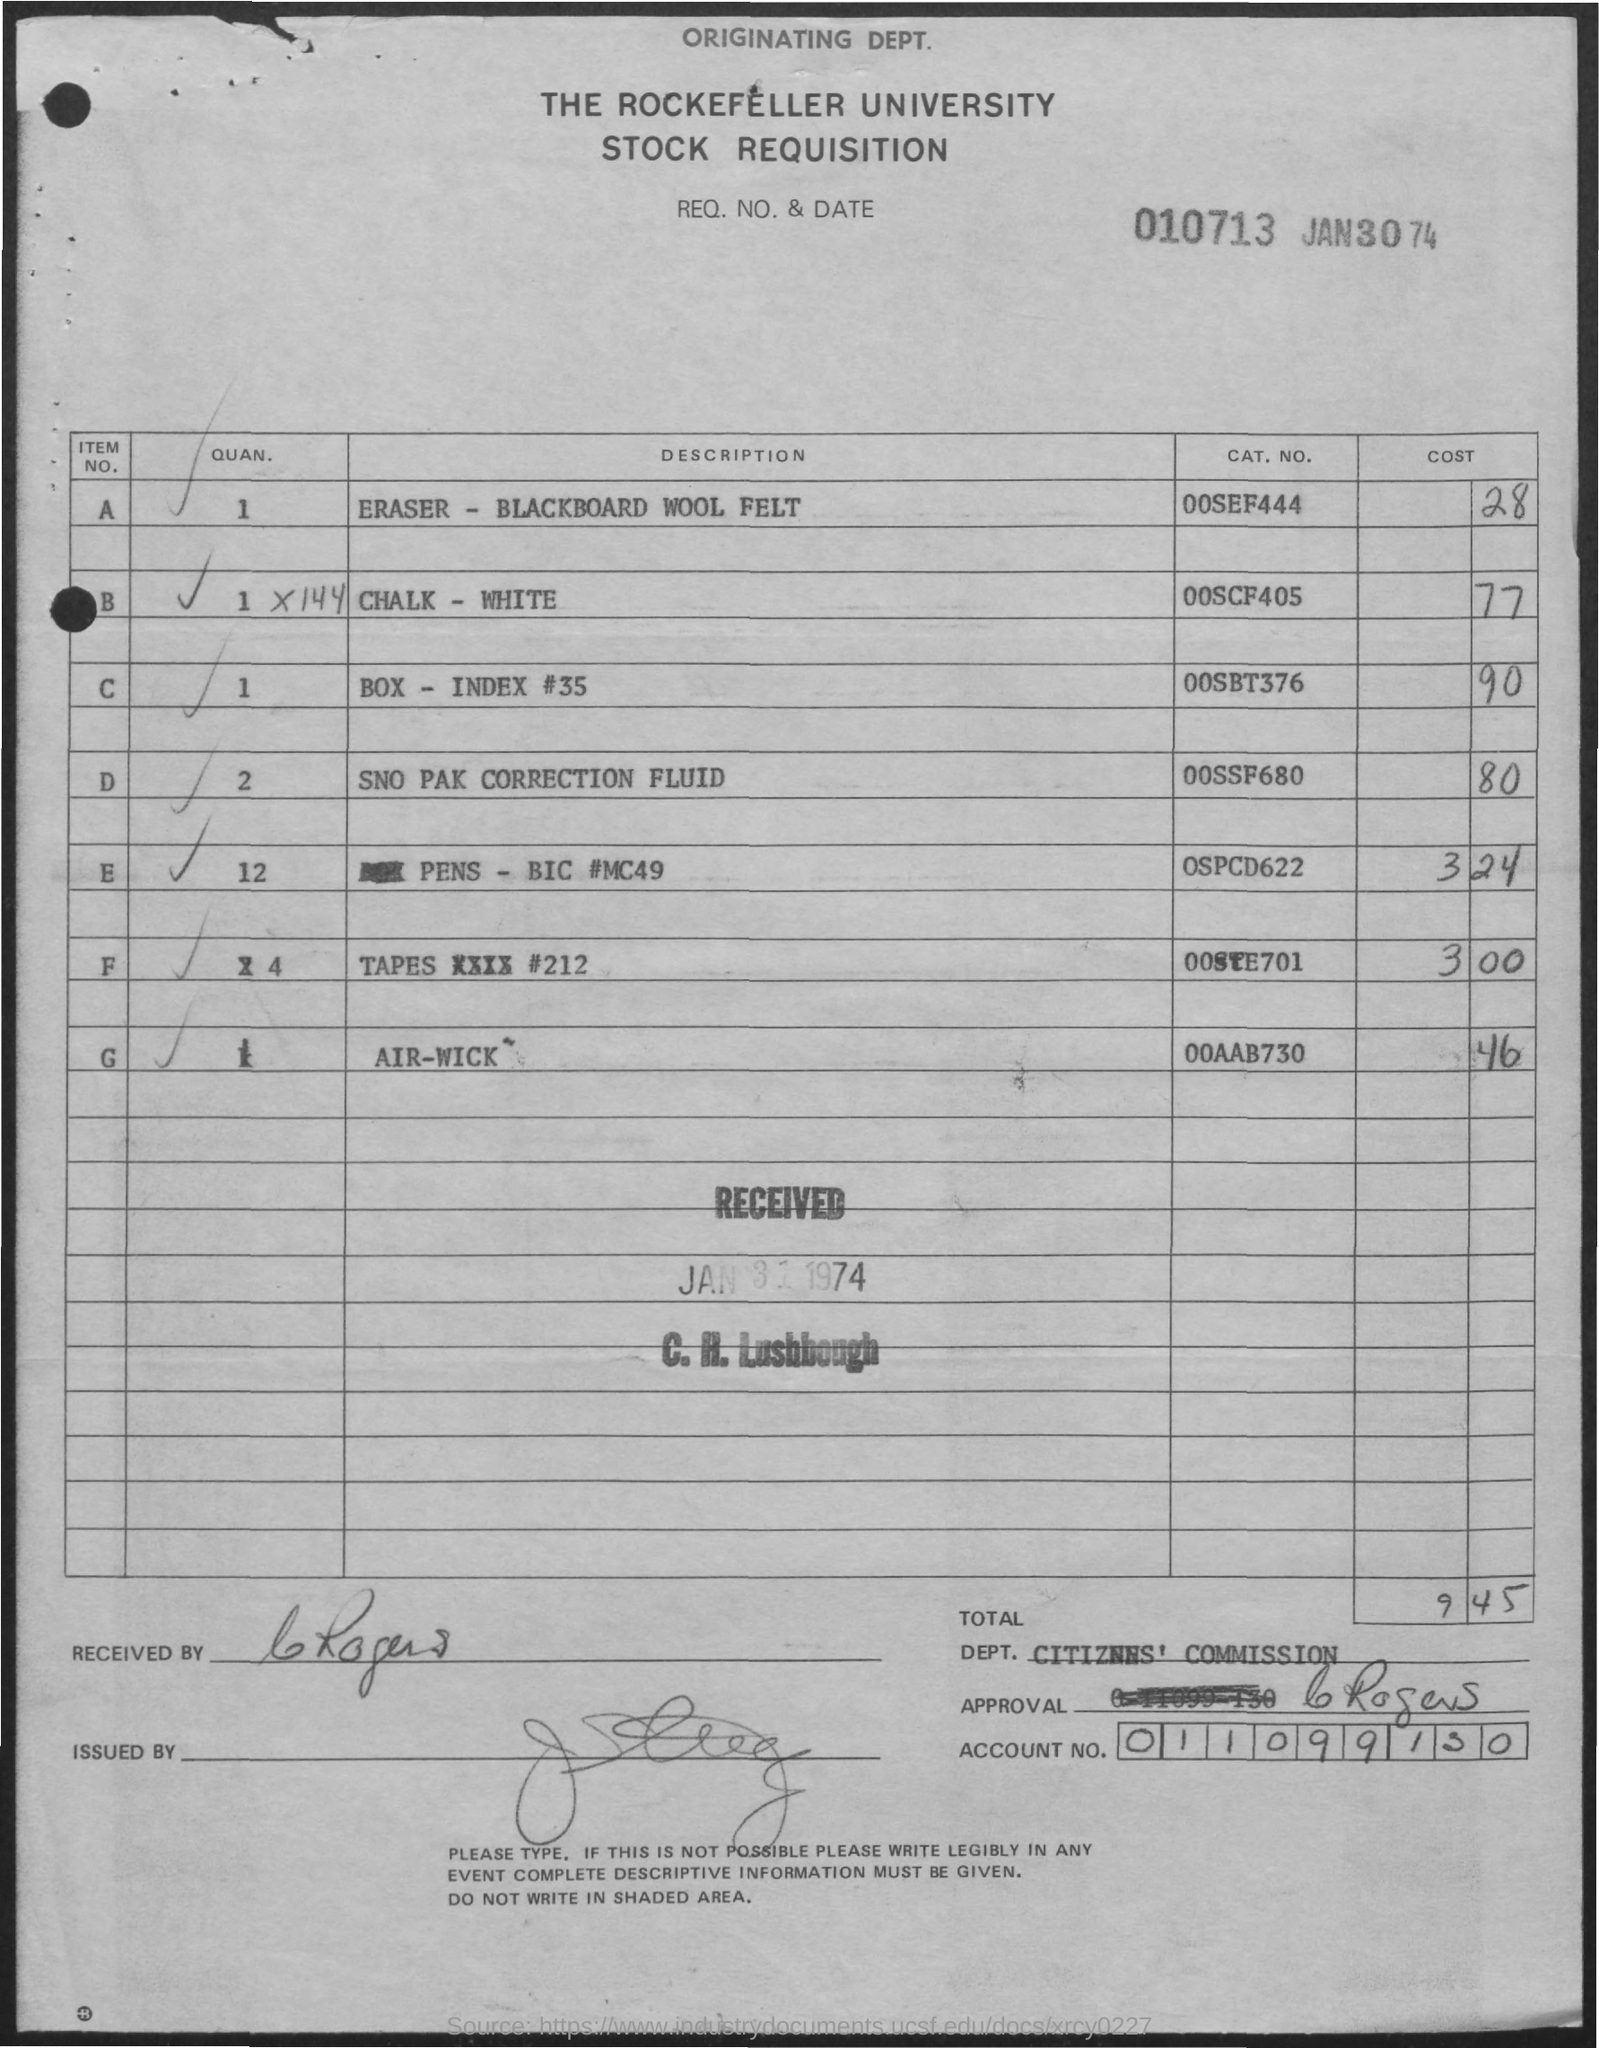What is the name of the University mentioned on the top?
Offer a terse response. THE ROCKFELLER UNIVERSITY. By whom was this document received?
Provide a succinct answer. C. H. Lushbough. What is the date mentioned at the top?
Provide a succinct answer. JAN30 74. 